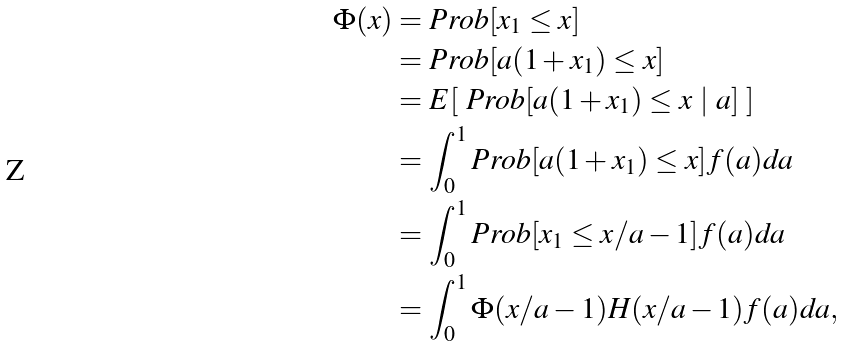<formula> <loc_0><loc_0><loc_500><loc_500>\Phi ( x ) & = P r o b [ x _ { 1 } \leq x ] \\ & = P r o b [ a ( 1 + x _ { 1 } ) \leq x ] \\ & = E [ \ P r o b [ a ( 1 + x _ { 1 } ) \leq x \ | \ a ] \ ] \\ & = \int _ { 0 } ^ { 1 } P r o b [ a ( 1 + x _ { 1 } ) \leq x ] f ( a ) d a \\ & = \int _ { 0 } ^ { 1 } P r o b [ x _ { 1 } \leq x / a - 1 ] f ( a ) d a \\ & = \int _ { 0 } ^ { 1 } \Phi ( x / a - 1 ) H ( x / a - 1 ) f ( a ) d a ,</formula> 